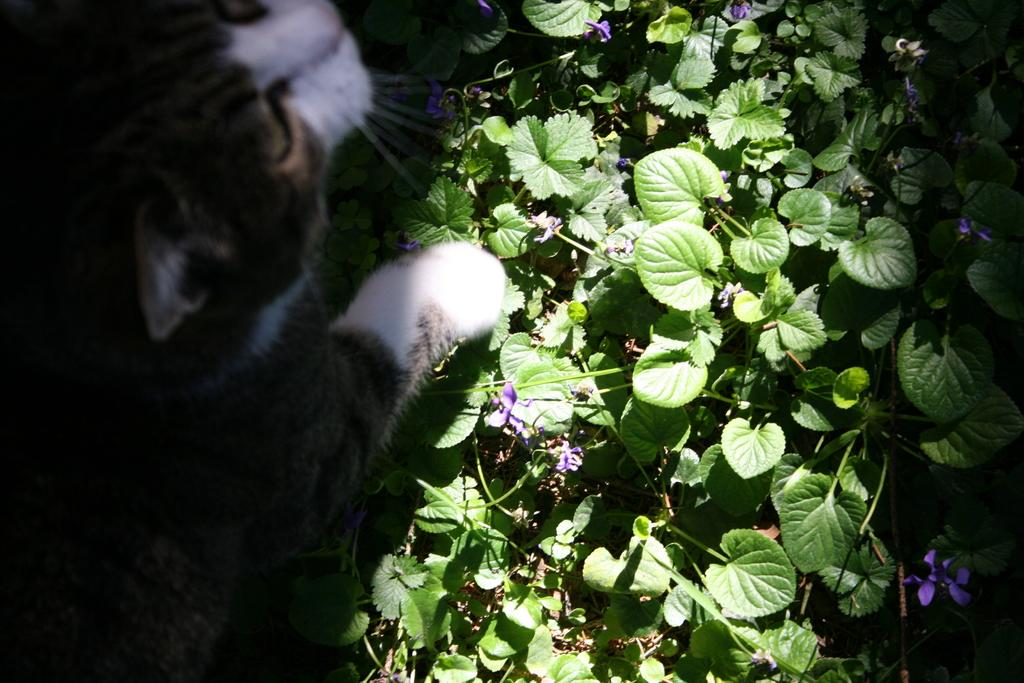What type of animal is in the picture? There is a cat in the picture. What else can be seen in the picture besides the cat? There are many plants in the picture. Are there any specific features of the plants? Some of the plants have flowers. What type of dress is the cat wearing in the picture? There is no dress present in the image, as cats do not wear clothing. 